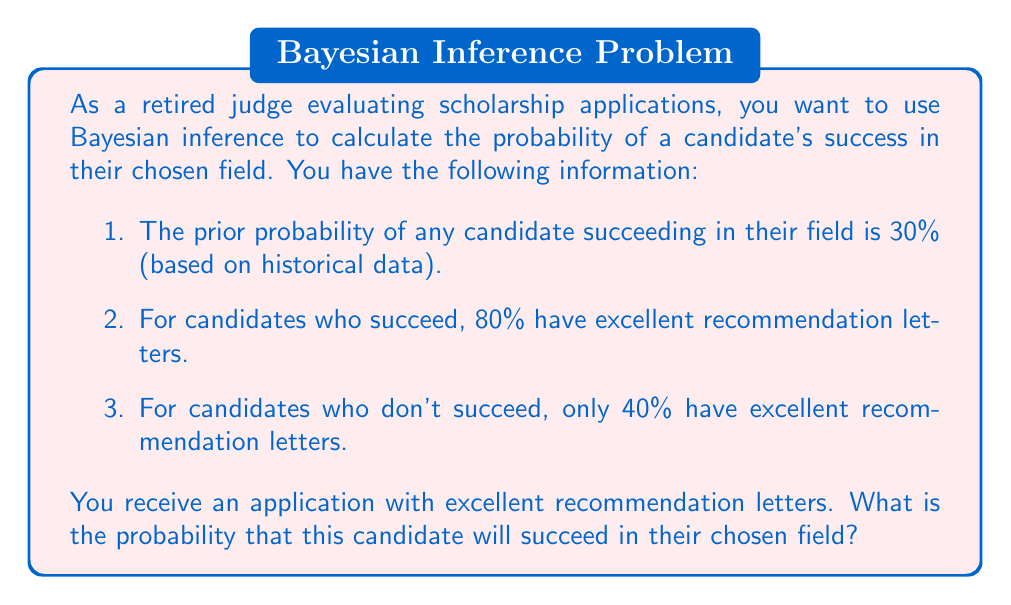Give your solution to this math problem. Let's approach this problem using Bayesian inference:

1. Define our events:
   $S$: The candidate succeeds in their chosen field
   $E$: The candidate has excellent recommendation letters

2. Given information:
   $P(S)$ = 0.30 (prior probability of success)
   $P(E|S)$ = 0.80 (probability of excellent letters given success)
   $P(E|\neg S)$ = 0.40 (probability of excellent letters given no success)

3. We want to find $P(S|E)$, the probability of success given excellent letters.

4. Bayes' theorem states:

   $$P(S|E) = \frac{P(E|S) \cdot P(S)}{P(E)}$$

5. We need to calculate $P(E)$ using the law of total probability:

   $$P(E) = P(E|S) \cdot P(S) + P(E|\neg S) \cdot P(\neg S)$$

6. Calculate $P(\neg S)$:
   $P(\neg S) = 1 - P(S) = 1 - 0.30 = 0.70$

7. Now calculate $P(E)$:
   $$P(E) = 0.80 \cdot 0.30 + 0.40 \cdot 0.70 = 0.24 + 0.28 = 0.52$$

8. Apply Bayes' theorem:

   $$P(S|E) = \frac{0.80 \cdot 0.30}{0.52} = \frac{0.24}{0.52} \approx 0.4615$$

Therefore, the probability that the candidate with excellent recommendation letters will succeed in their chosen field is approximately 0.4615 or 46.15%.
Answer: The probability that the candidate with excellent recommendation letters will succeed in their chosen field is approximately 0.4615 or 46.15%. 